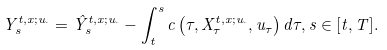<formula> <loc_0><loc_0><loc_500><loc_500>Y _ { s } ^ { t , x ; u _ { \cdot } } = \hat { Y } _ { s } ^ { t , x ; u _ { \cdot } } - \int _ { t } ^ { s } c \left ( \tau , X _ { \tau } ^ { t , x ; u _ { \cdot } } , u _ { \tau } \right ) d \tau , s \in [ t , T ] .</formula> 